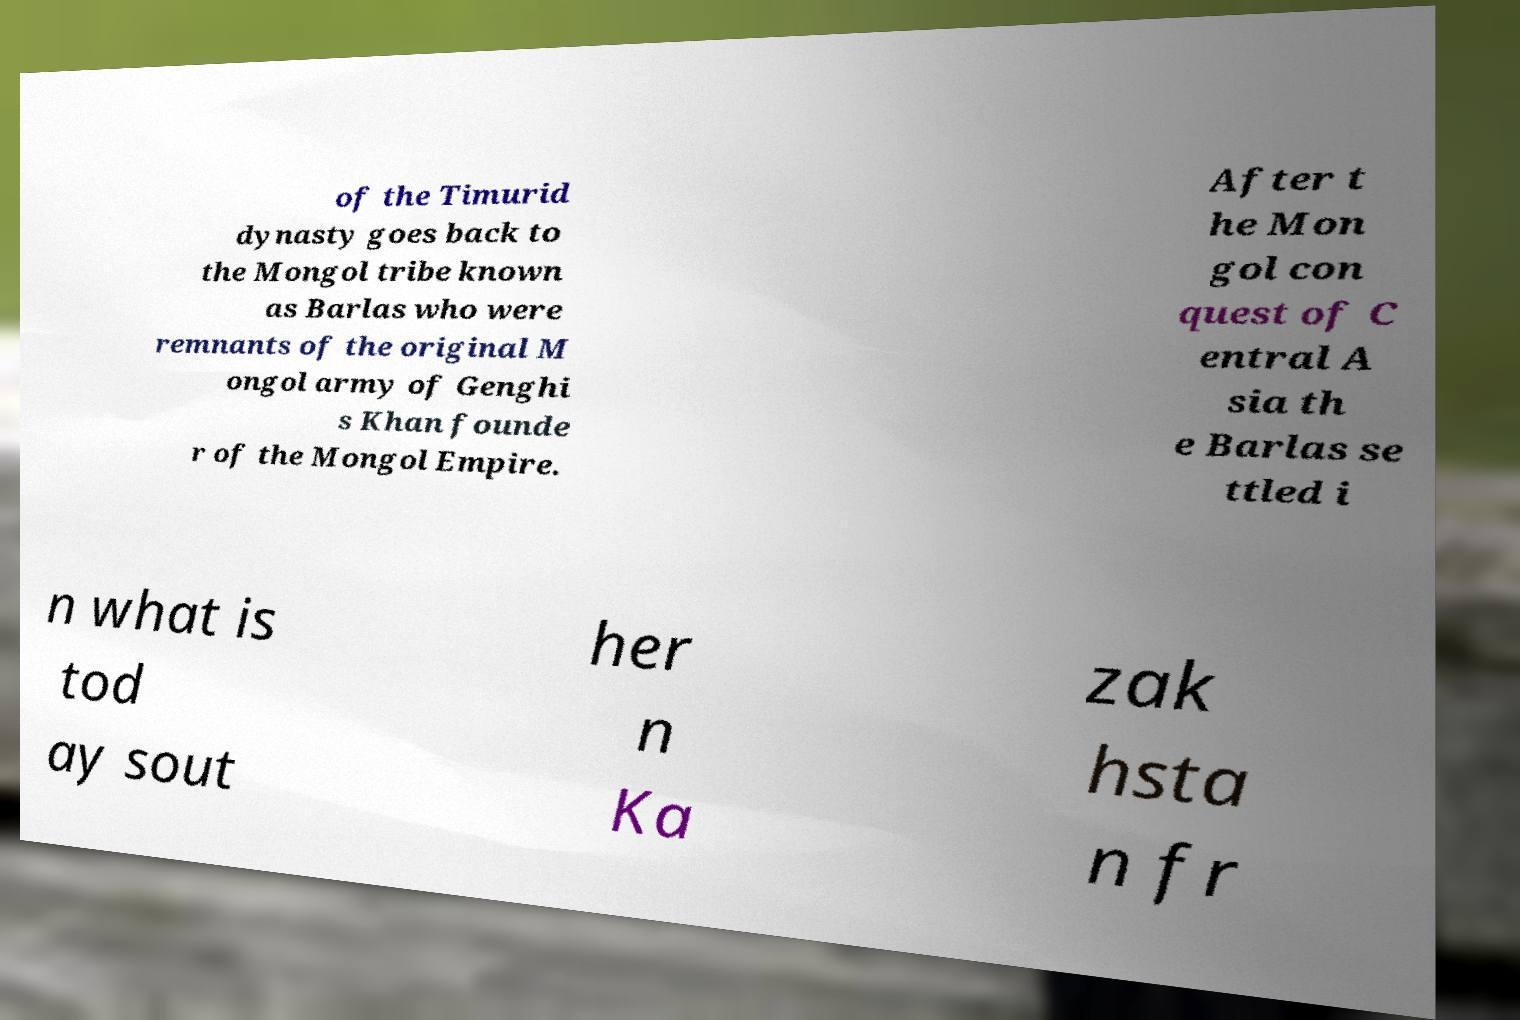Please identify and transcribe the text found in this image. of the Timurid dynasty goes back to the Mongol tribe known as Barlas who were remnants of the original M ongol army of Genghi s Khan founde r of the Mongol Empire. After t he Mon gol con quest of C entral A sia th e Barlas se ttled i n what is tod ay sout her n Ka zak hsta n fr 